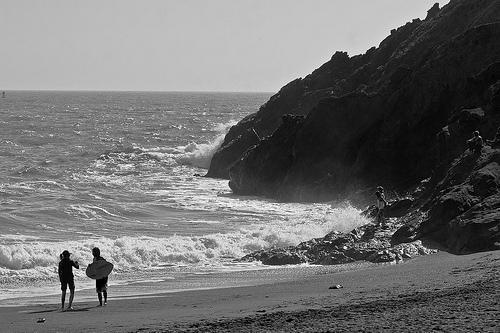How many people?
Give a very brief answer. 4. 